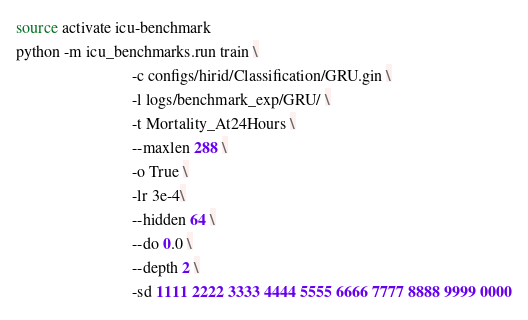Convert code to text. <code><loc_0><loc_0><loc_500><loc_500><_Bash_>source activate icu-benchmark
python -m icu_benchmarks.run train \
                             -c configs/hirid/Classification/GRU.gin \
                             -l logs/benchmark_exp/GRU/ \
                             -t Mortality_At24Hours \
                             --maxlen 288 \
                             -o True \
                             -lr 3e-4\
                             --hidden 64 \
                             --do 0.0 \
                             --depth 2 \
                             -sd 1111 2222 3333 4444 5555 6666 7777 8888 9999 0000

</code> 